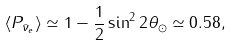<formula> <loc_0><loc_0><loc_500><loc_500>\langle P _ { \bar { \nu } _ { e } } \rangle \simeq 1 - \frac { 1 } { 2 } \sin ^ { 2 } 2 \theta _ { \odot } \simeq 0 . 5 8 ,</formula> 